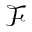Convert formula to latex. <formula><loc_0><loc_0><loc_500><loc_500>\mathcal { F }</formula> 